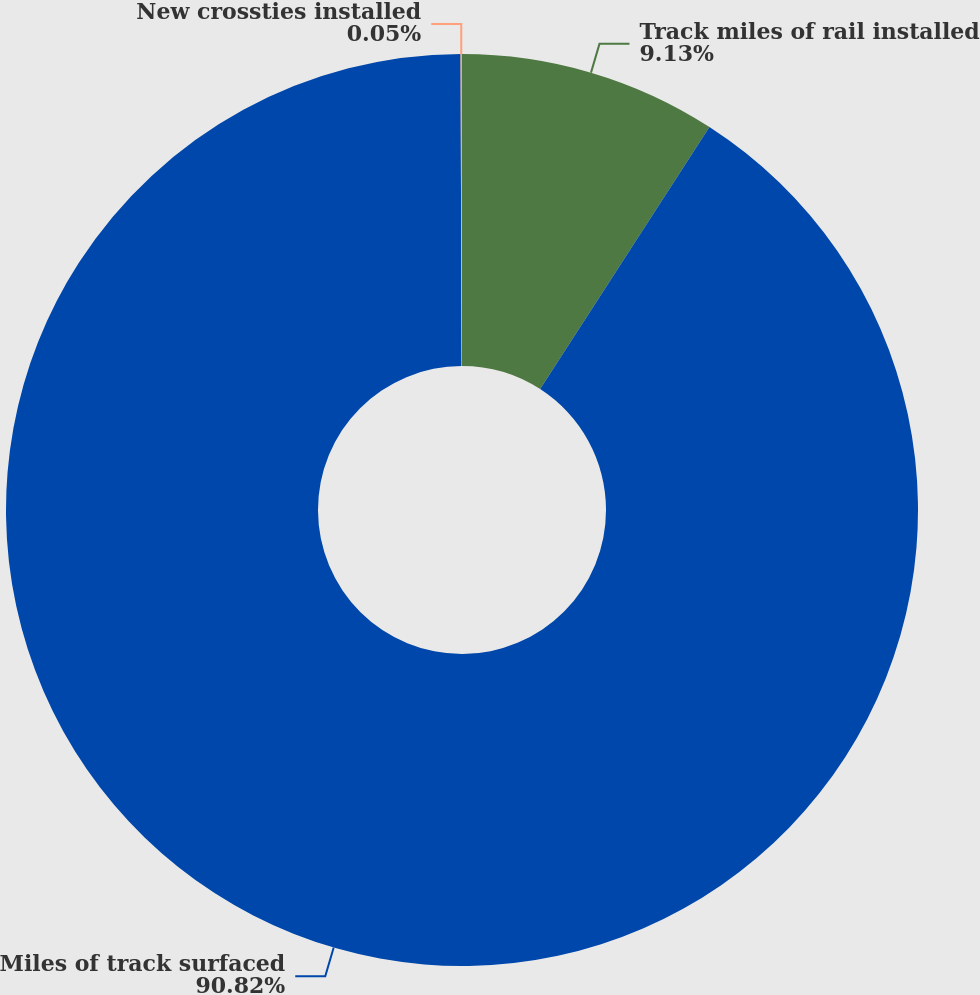Convert chart. <chart><loc_0><loc_0><loc_500><loc_500><pie_chart><fcel>Track miles of rail installed<fcel>Miles of track surfaced<fcel>New crossties installed<nl><fcel>9.13%<fcel>90.83%<fcel>0.05%<nl></chart> 